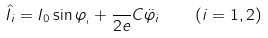<formula> <loc_0><loc_0><loc_500><loc_500>\hat { I } _ { i } = I _ { 0 } \sin \varphi _ { _ { i } } + \frac { } { 2 e } C \ddot { \varphi } _ { i } \quad \left ( { i = 1 , 2 } \right )</formula> 